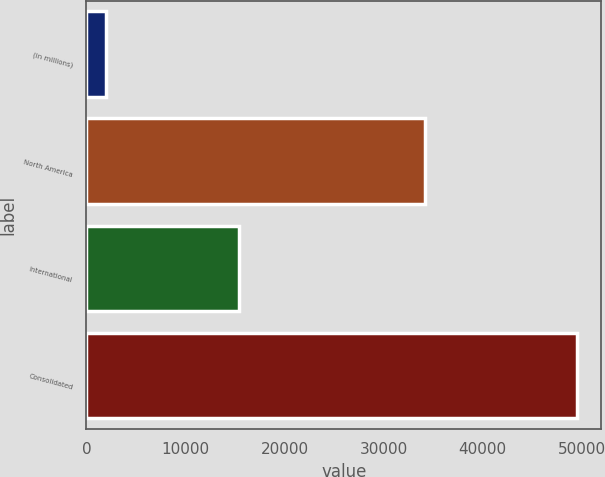<chart> <loc_0><loc_0><loc_500><loc_500><bar_chart><fcel>(in millions)<fcel>North America<fcel>International<fcel>Consolidated<nl><fcel>2017<fcel>34149<fcel>15371<fcel>49520<nl></chart> 